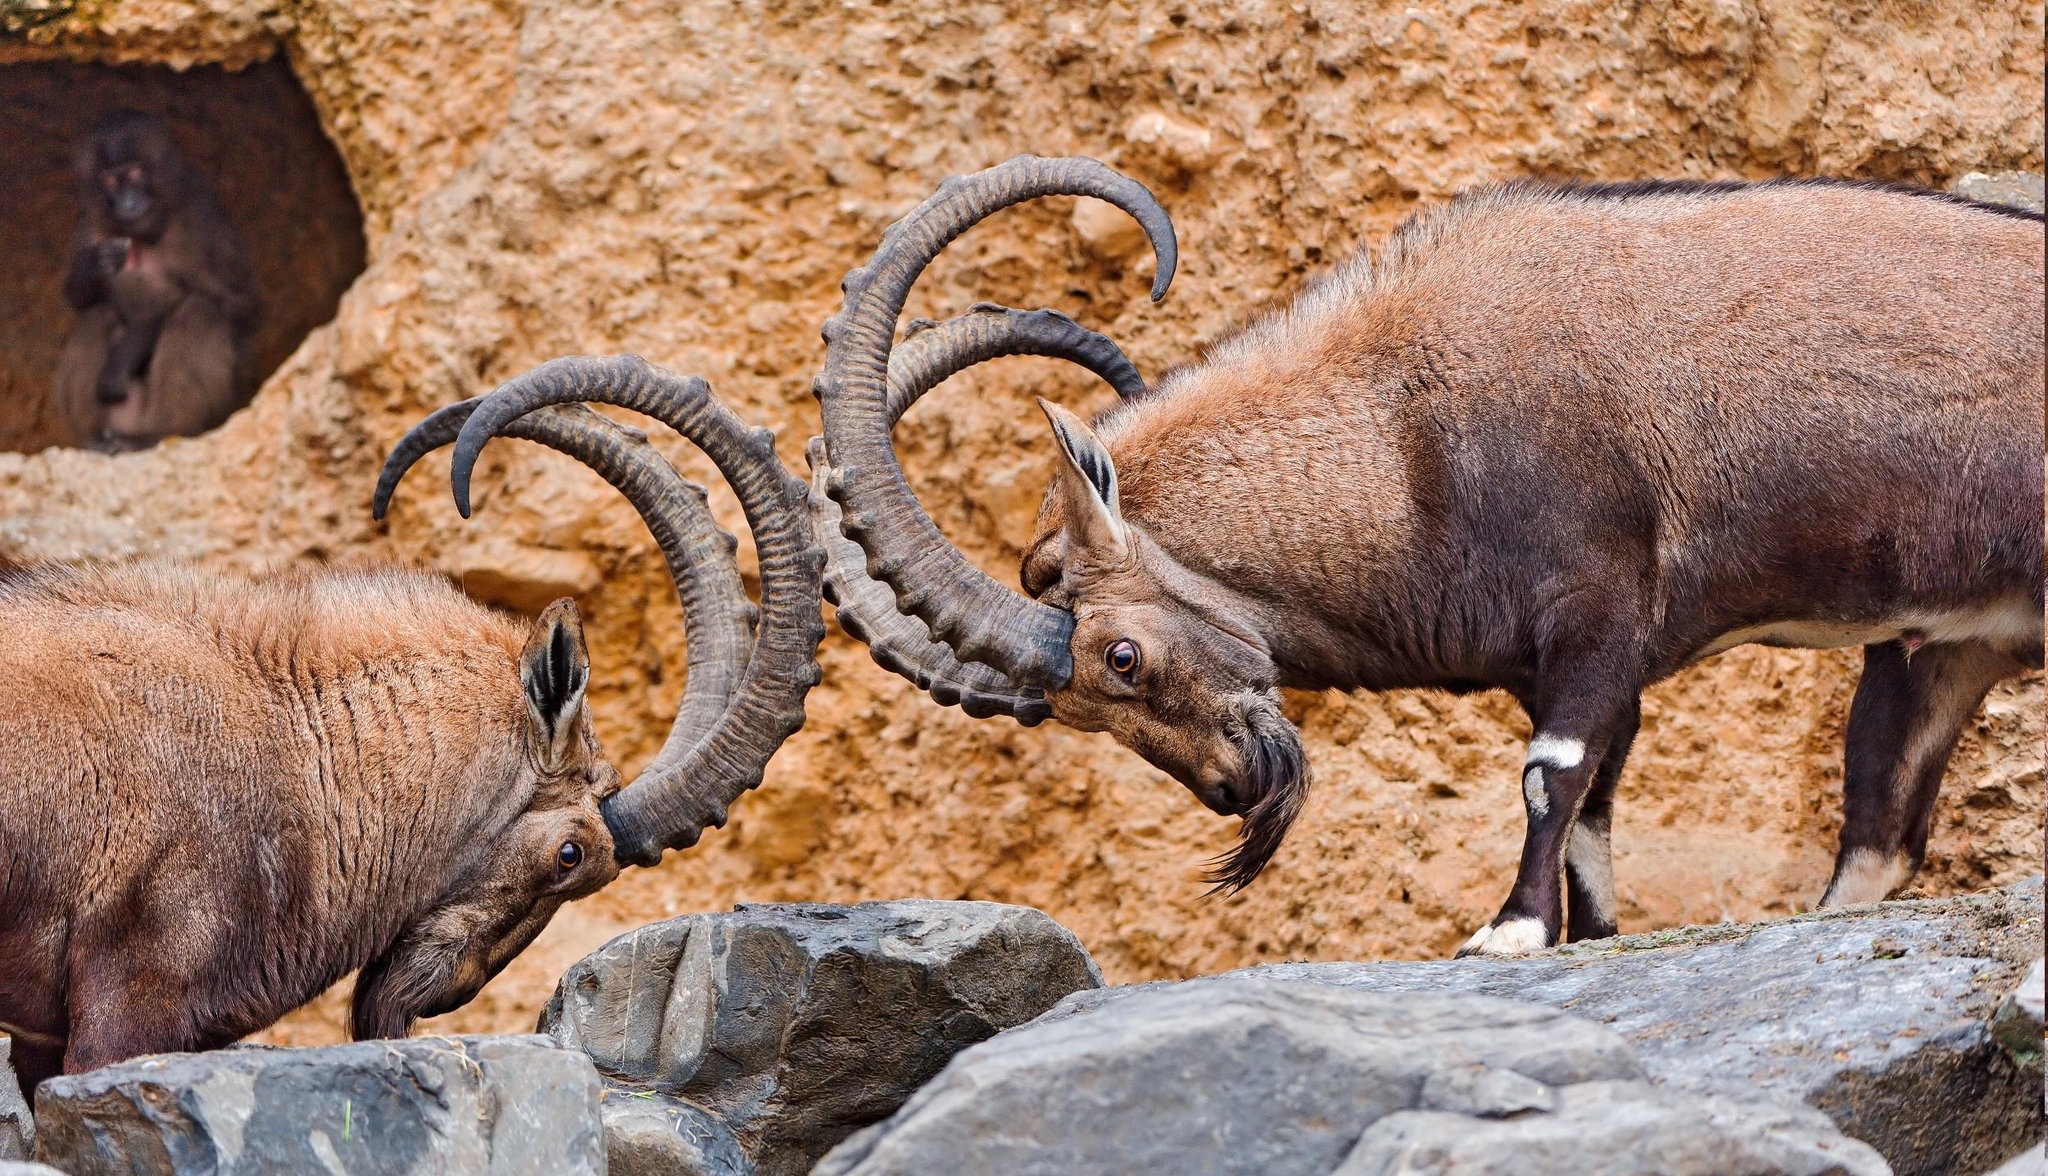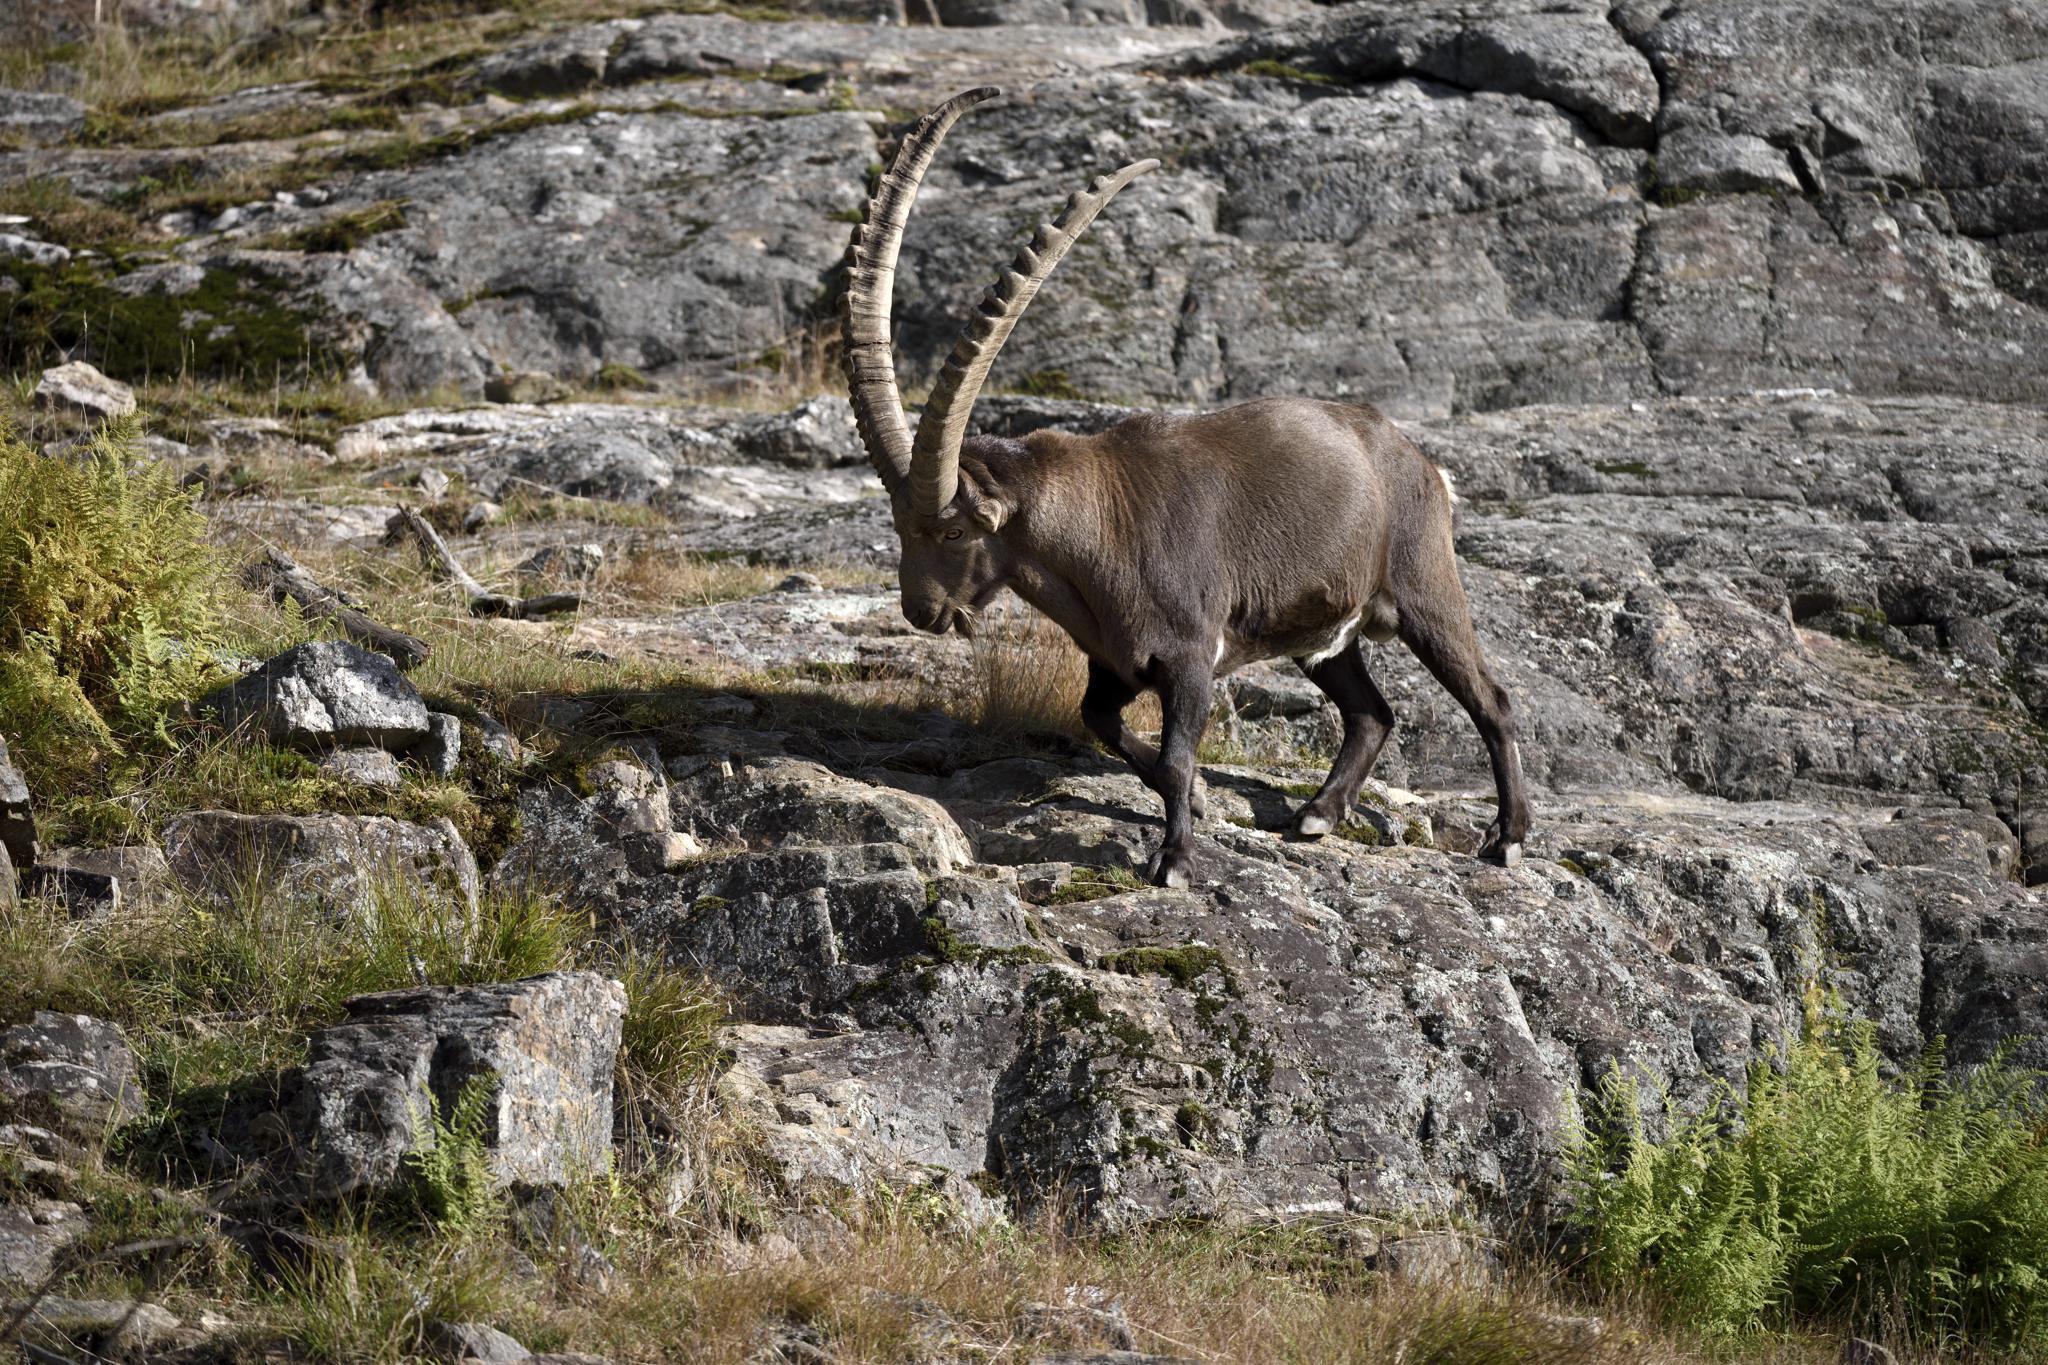The first image is the image on the left, the second image is the image on the right. Assess this claim about the two images: "In one image an animal with long, curved horns is standing in a rocky area, while a similar animal in the other image is lying down with its head erect.". Correct or not? Answer yes or no. No. The first image is the image on the left, the second image is the image on the right. Evaluate the accuracy of this statement regarding the images: "Each image depicts exactly one long-horned hooved animal.". Is it true? Answer yes or no. No. 